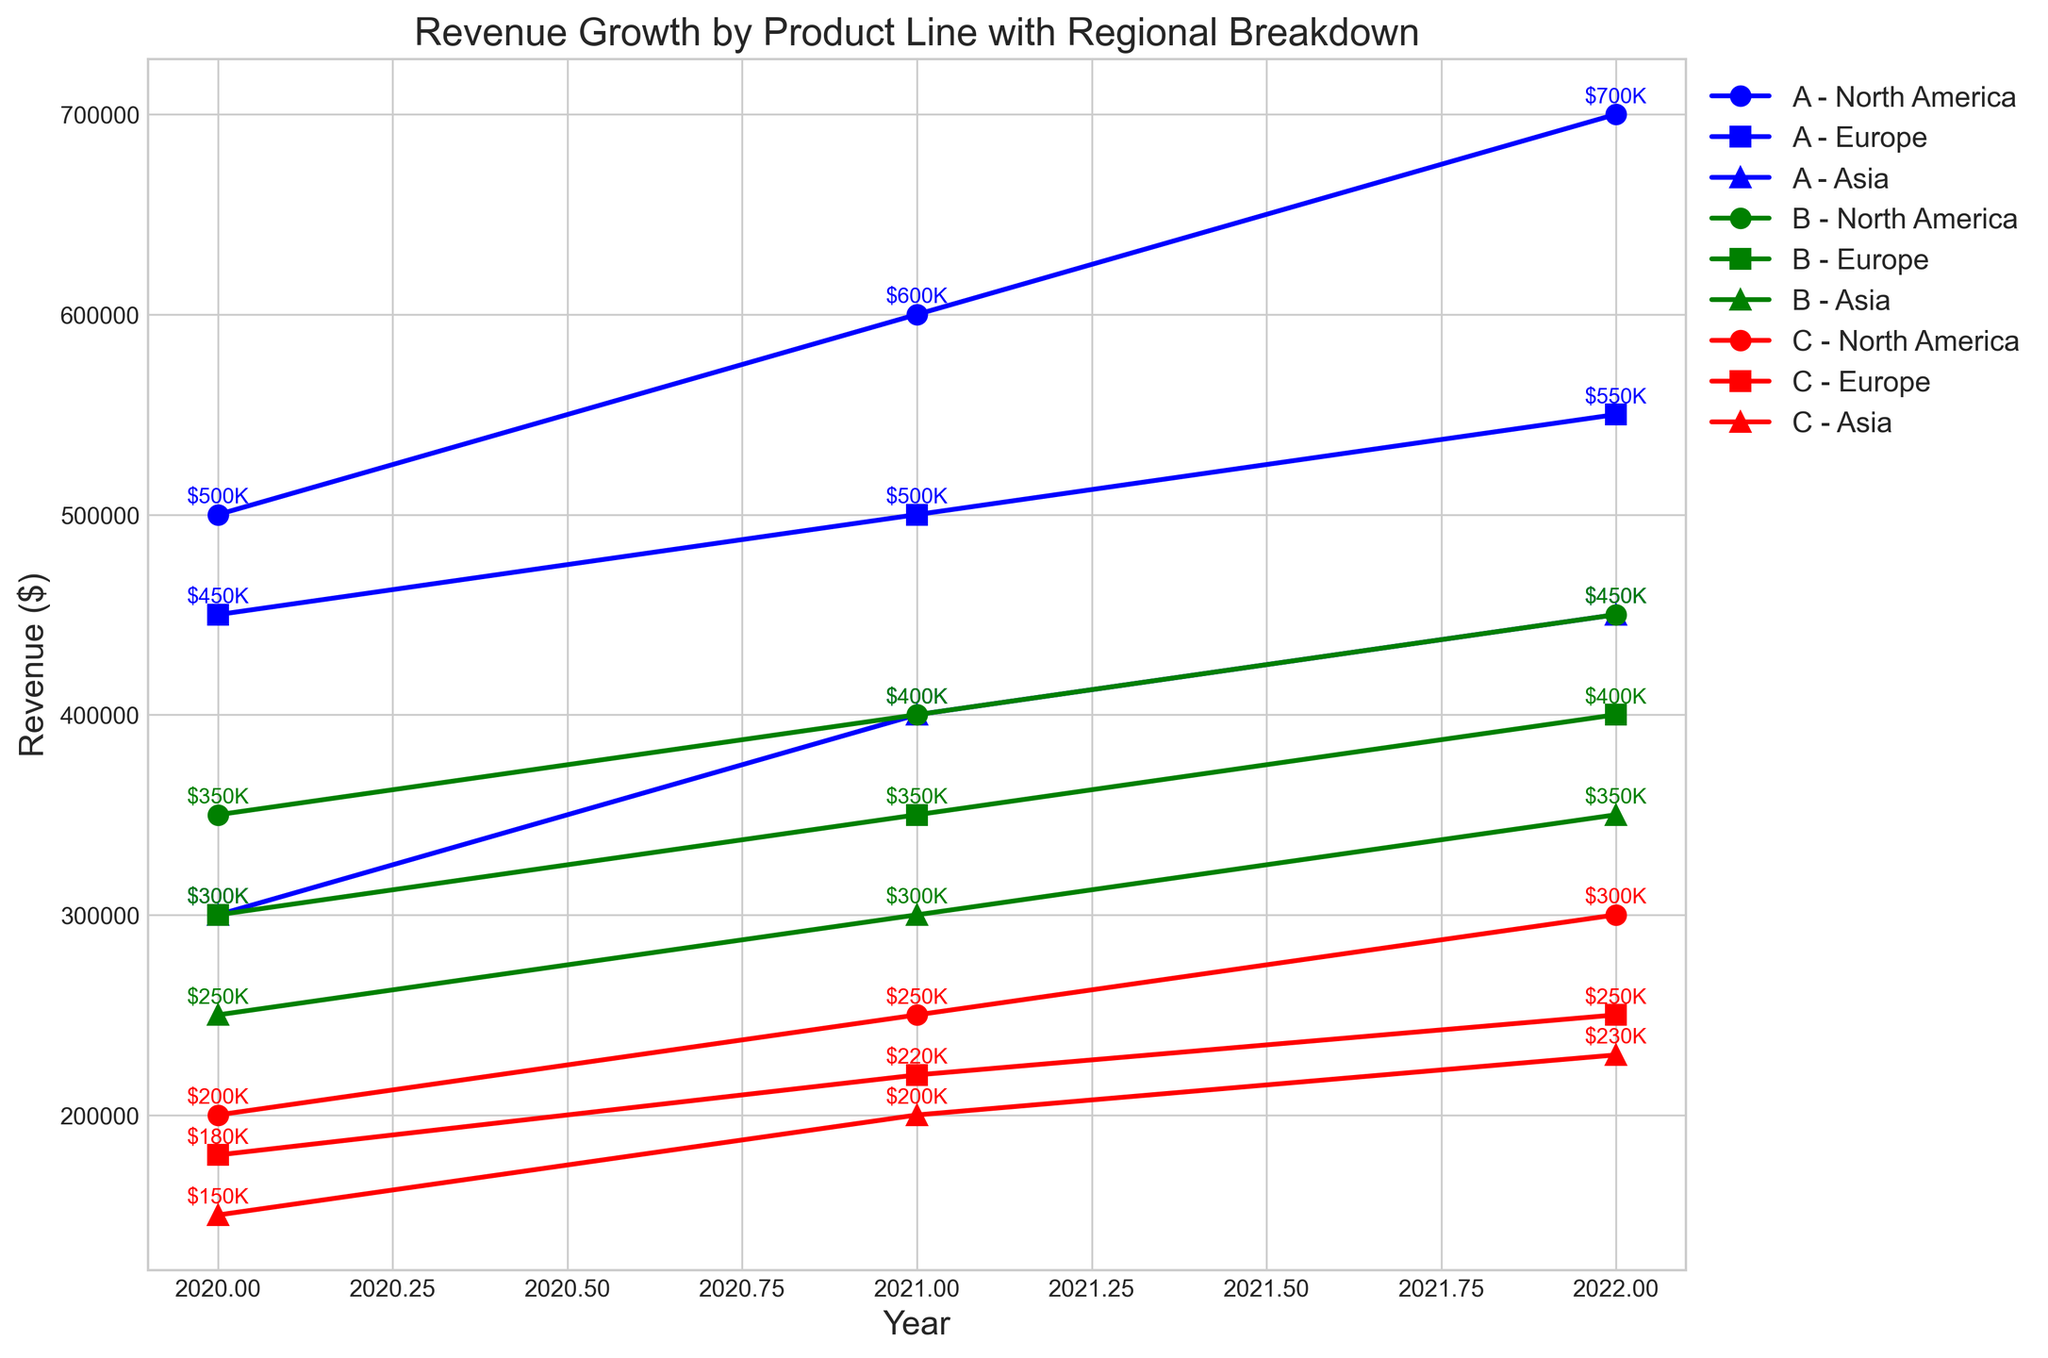What was the total revenue for Product Line A across all regions in 2022? Add the revenues for Product Line A in North America, Europe, and Asia for 2022: $700,000 (North America) + $550,000 (Europe) + $450,000 (Asia) = $1,700,000
Answer: $1,700,000 Which region had the highest revenue for Product Line B in 2021? Compare the revenues for Product Line B in 2021 across the three regions: North America ($400,000), Europe ($350,000), and Asia ($300,000). North America has the highest revenue.
Answer: North America For which product line and region did the revenue decrease from 2021 to 2022? Compare the revenues for each product line and region from 2021 to 2022. No revenue decreased for any combination in the data provided.
Answer: None How did the revenue for Product Line C in Europe change from 2020 to 2021 and from 2021 to 2022? Check the revenue values for Product Line C in Europe across the years: $180,000 in 2020, $220,000 in 2021, and $250,000 in 2022. From 2020 to 2021, the revenue increased by $40,000, and from 2021 to 2022, it increased by $30,000.
Answer: Increased by $40,000 and $30,000 Which product line showed the most consistent revenue growth across all regions from 2020 to 2022? Compare the revenue growth patterns for each product line across all regions. Product Line A had consistent growth; each region showed an increase every year. Product Line B and C also increased but had more varied growth rates.
Answer: Product Line A What was the difference in revenue between Product Line A and Product Line C in North America in 2022? Subtract the revenue of Product Line C from Product Line A in North America for 2022: $700,000 (A) - $300,000 (C) = $400,000
Answer: $400,000 Which year had the highest revenue for Product Line B in Asia, and what was the revenue? Compare the yearly revenues for Product Line B in Asia: $250,000 (2020), $300,000 (2021), and $350,000 (2022). The highest revenue was in 2022, with $350,000.
Answer: 2022, $350,000 How much did the total revenue for Europe increase from 2020 to 2022 for all product lines combined? Calculate the total revenue for Europe in 2020 and 2022 for all product lines, then find the difference. 2020: $450,000 (A) + $300,000 (B) + $180,000 (C) = $930,000. 2022: $550,000 (A) + $400,000 (B) + $250,000 (C) = $1,200,000. Increase: $1,200,000 - $930,000 = $270,000.
Answer: $270,000 What proportion of the total revenue for Product Line A in 2020 came from Asia? Calculate the percentage: Asia's revenue ($300,000) / Total revenue for Product Line A in 2020 ($500,000 + $450,000 + $300,000) = $300,000 / $1,250,000 ≈ 0.24 or 24%.
Answer: 24% Which product line and region combination had the smallest revenue in 2021? Compare the revenues for all product lines and regions in 2021. The smallest revenue is for Product Line C in Asia, with $200,000.
Answer: Product Line C, Asia 